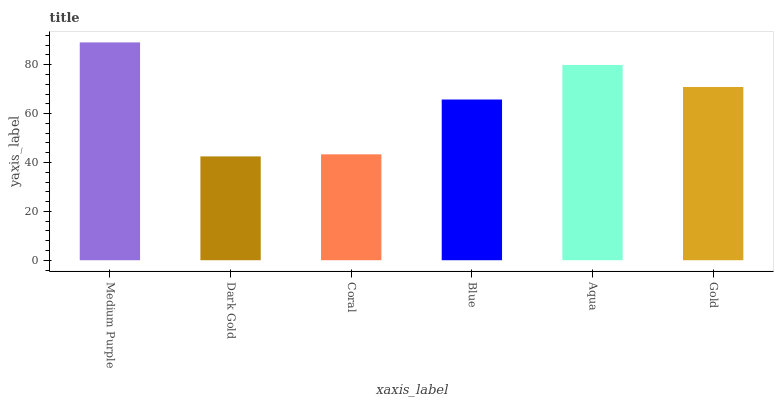Is Coral the minimum?
Answer yes or no. No. Is Coral the maximum?
Answer yes or no. No. Is Coral greater than Dark Gold?
Answer yes or no. Yes. Is Dark Gold less than Coral?
Answer yes or no. Yes. Is Dark Gold greater than Coral?
Answer yes or no. No. Is Coral less than Dark Gold?
Answer yes or no. No. Is Gold the high median?
Answer yes or no. Yes. Is Blue the low median?
Answer yes or no. Yes. Is Aqua the high median?
Answer yes or no. No. Is Dark Gold the low median?
Answer yes or no. No. 